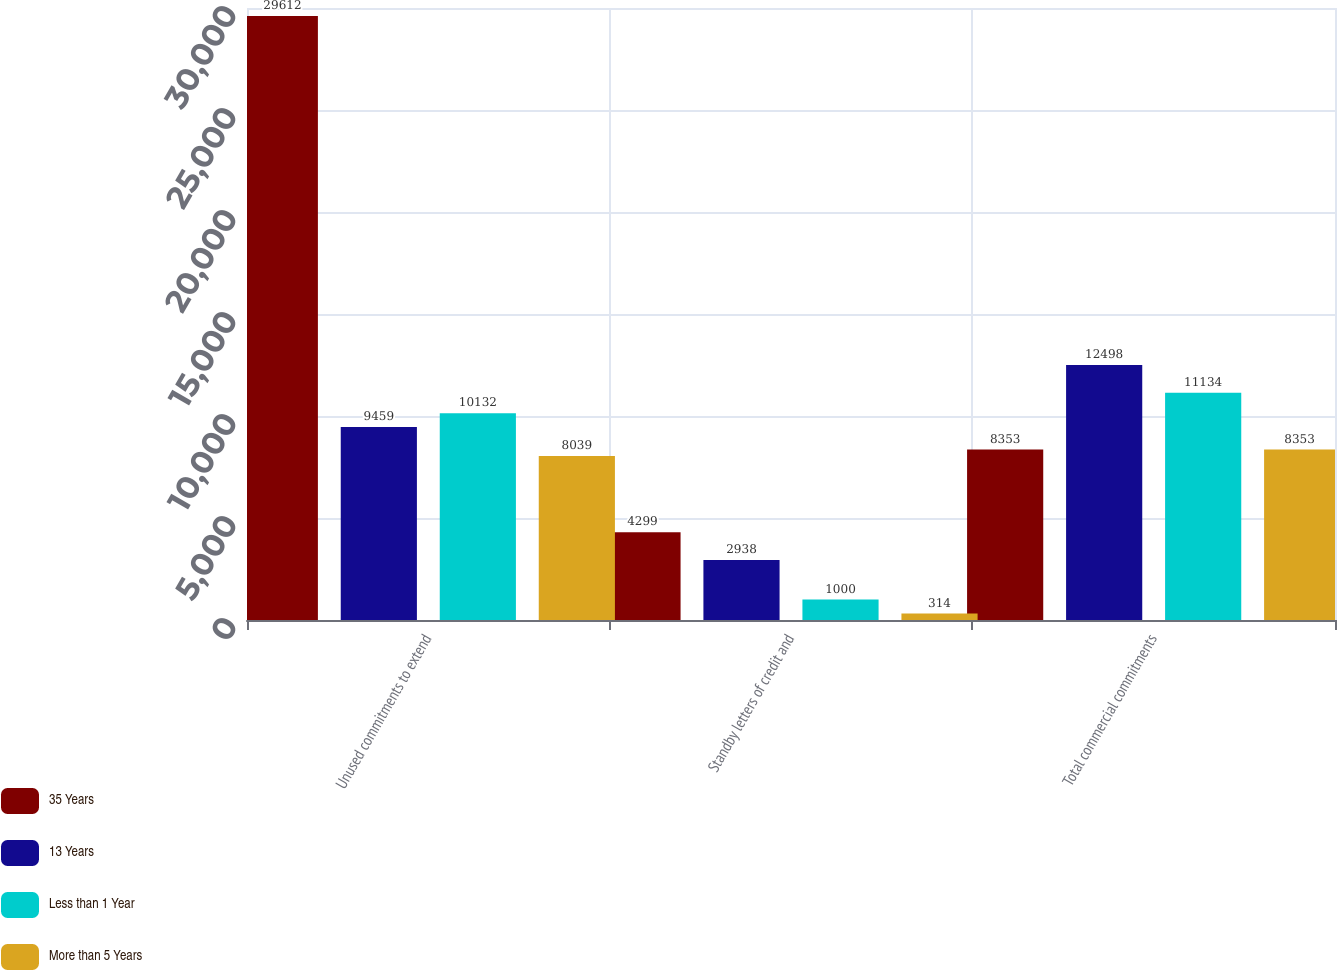<chart> <loc_0><loc_0><loc_500><loc_500><stacked_bar_chart><ecel><fcel>Unused commitments to extend<fcel>Standby letters of credit and<fcel>Total commercial commitments<nl><fcel>35 Years<fcel>29612<fcel>4299<fcel>8353<nl><fcel>13 Years<fcel>9459<fcel>2938<fcel>12498<nl><fcel>Less than 1 Year<fcel>10132<fcel>1000<fcel>11134<nl><fcel>More than 5 Years<fcel>8039<fcel>314<fcel>8353<nl></chart> 